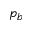Convert formula to latex. <formula><loc_0><loc_0><loc_500><loc_500>p _ { b }</formula> 